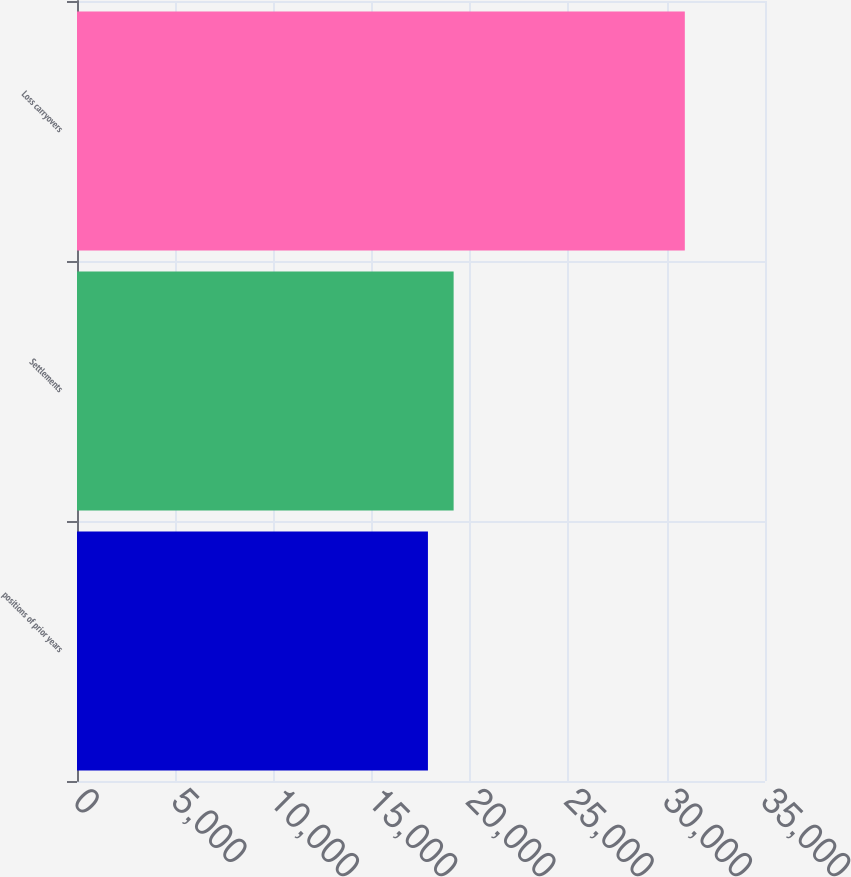<chart> <loc_0><loc_0><loc_500><loc_500><bar_chart><fcel>positions of prior years<fcel>Settlements<fcel>Loss carryovers<nl><fcel>17853<fcel>19159.8<fcel>30921<nl></chart> 